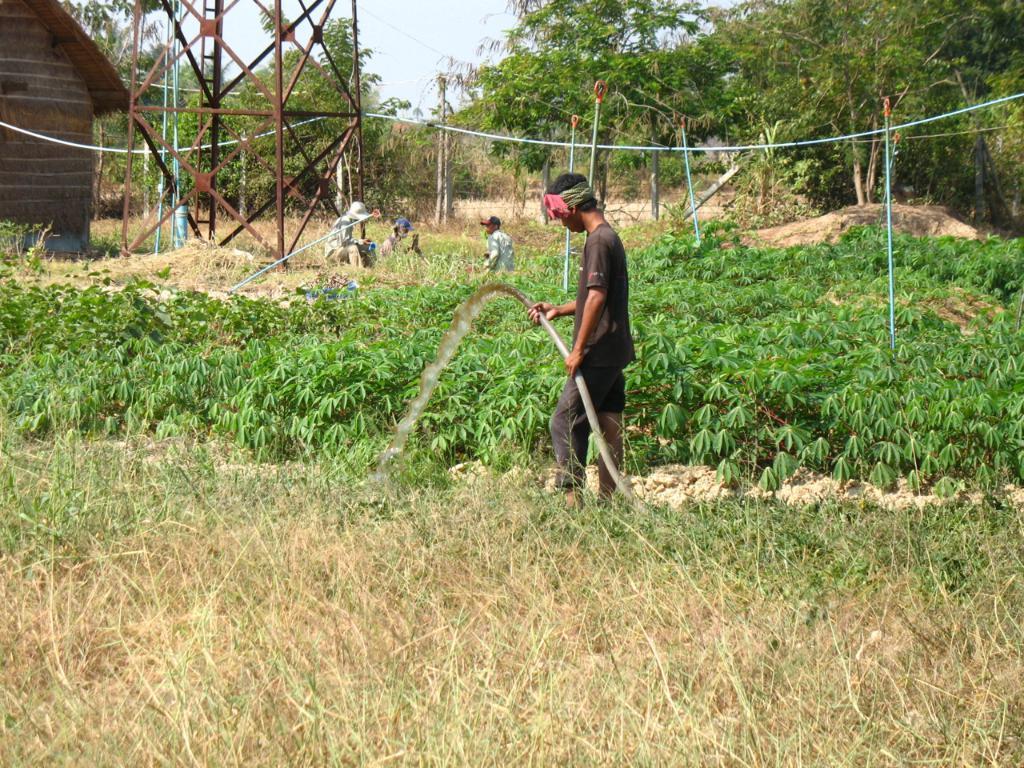In one or two sentences, can you explain what this image depicts? In the center of the image, we can see a person holding a water pipe and in the background, there are plants, trees, poles along with wires, a tower and we can see a shed and we can see some people. At the bottom, there is grass and at the top, there is sky. 